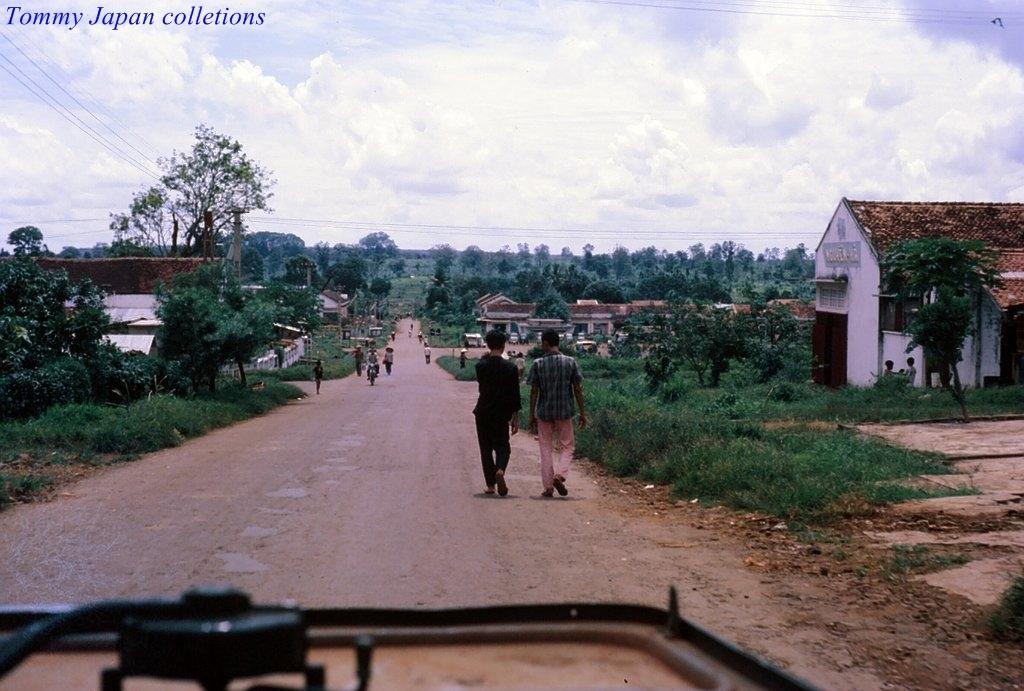What is happening on the road in the image? There are many people moving on the road. What can be seen on either side of the road? There are trees, plants, and houses on either side of the road. What is visible in the background of the image? The sky is visible in the background of the image. What type of alarm is being used by the people on the road? There is no alarm present in the image; people are simply moving on the road. Are the people wearing masks in the image? There is no mention of masks in the image; people are just moving on the road. 